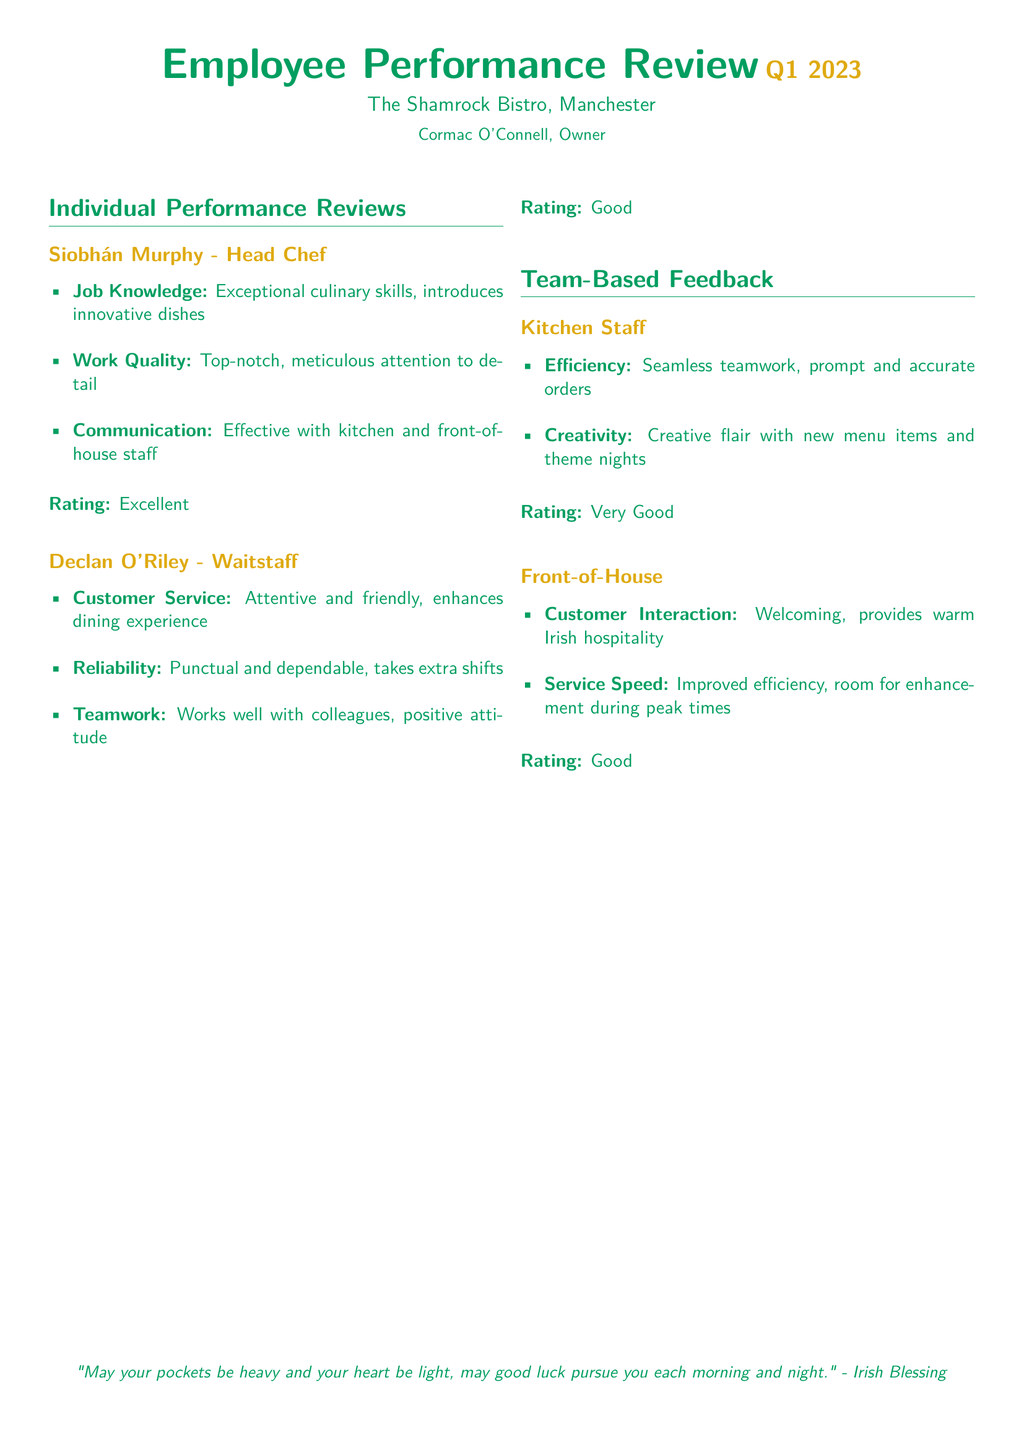What is the name of the restaurant? The document clearly states the name of the restaurant at the top, which is mentioned as "The Shamrock Bistro."
Answer: The Shamrock Bistro Who is the owner of the restaurant? The document identifies the owner of the restaurant in the introductory section as "Cormac O'Connell."
Answer: Cormac O'Connell How many individual performance reviews are there? The document lists two individual performance reviews under the "Individual Performance Reviews" section, which can be counted.
Answer: 2 What is Siobhán Murphy's job title? The document specifies Siobhán Murphy's job title in her performance review section as "Head Chef."
Answer: Head Chef What rating did the Front-of-House team receive? The team feedback section indicates the rating received by the Front-of-House team specifically mentioned at the end of that section.
Answer: Good Which aspect did Declan O'Riley excel in according to his performance review? The performance review details different aspects, and it highlights that Declan O'Riley excelled in "Customer Service."
Answer: Customer Service What is one creative feature noticed in the Kitchen Staff performance review? The performance review for the Kitchen Staff notes their "Creative flair with new menu items and theme nights" as a standout feature.
Answer: Creative flair How is the teamwork of the Kitchen Staff described? The document provides a description of the teamwork exhibited by the Kitchen Staff, which is noted as "Seamless teamwork."
Answer: Seamless teamwork What is the main theme of the closing quote? The closing quote is an Irish blessing, conveying themes of luck and positivity, rooted in Irish culture.
Answer: Luck and positivity 